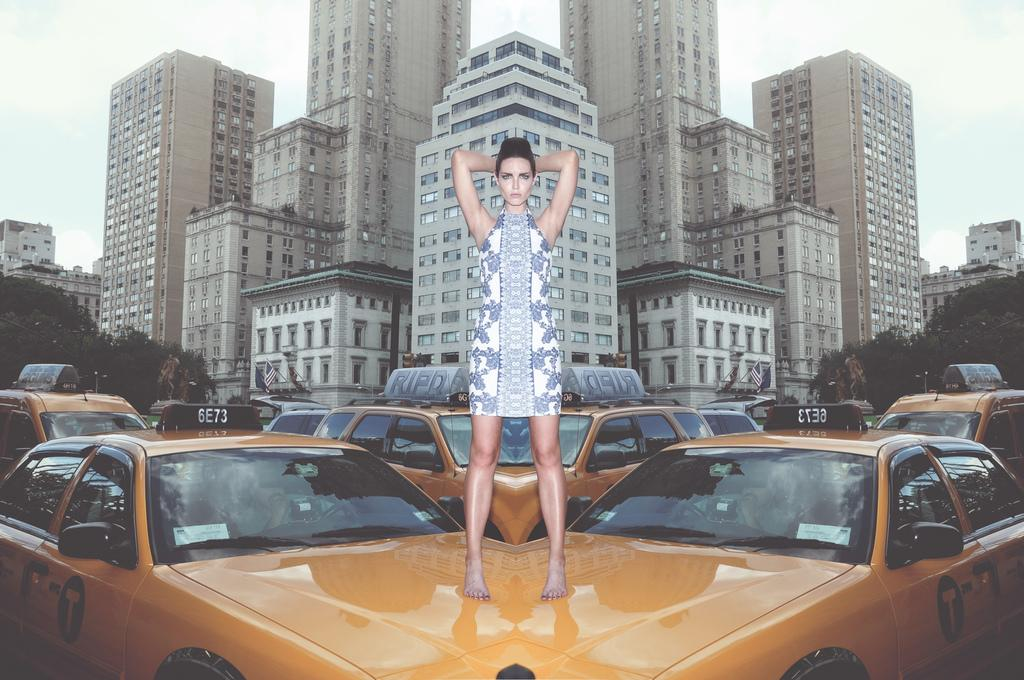<image>
Offer a succinct explanation of the picture presented. A model n a blue and white dress stands on a cab with number 6E73. 